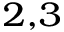<formula> <loc_0><loc_0><loc_500><loc_500>^ { 2 , 3 }</formula> 